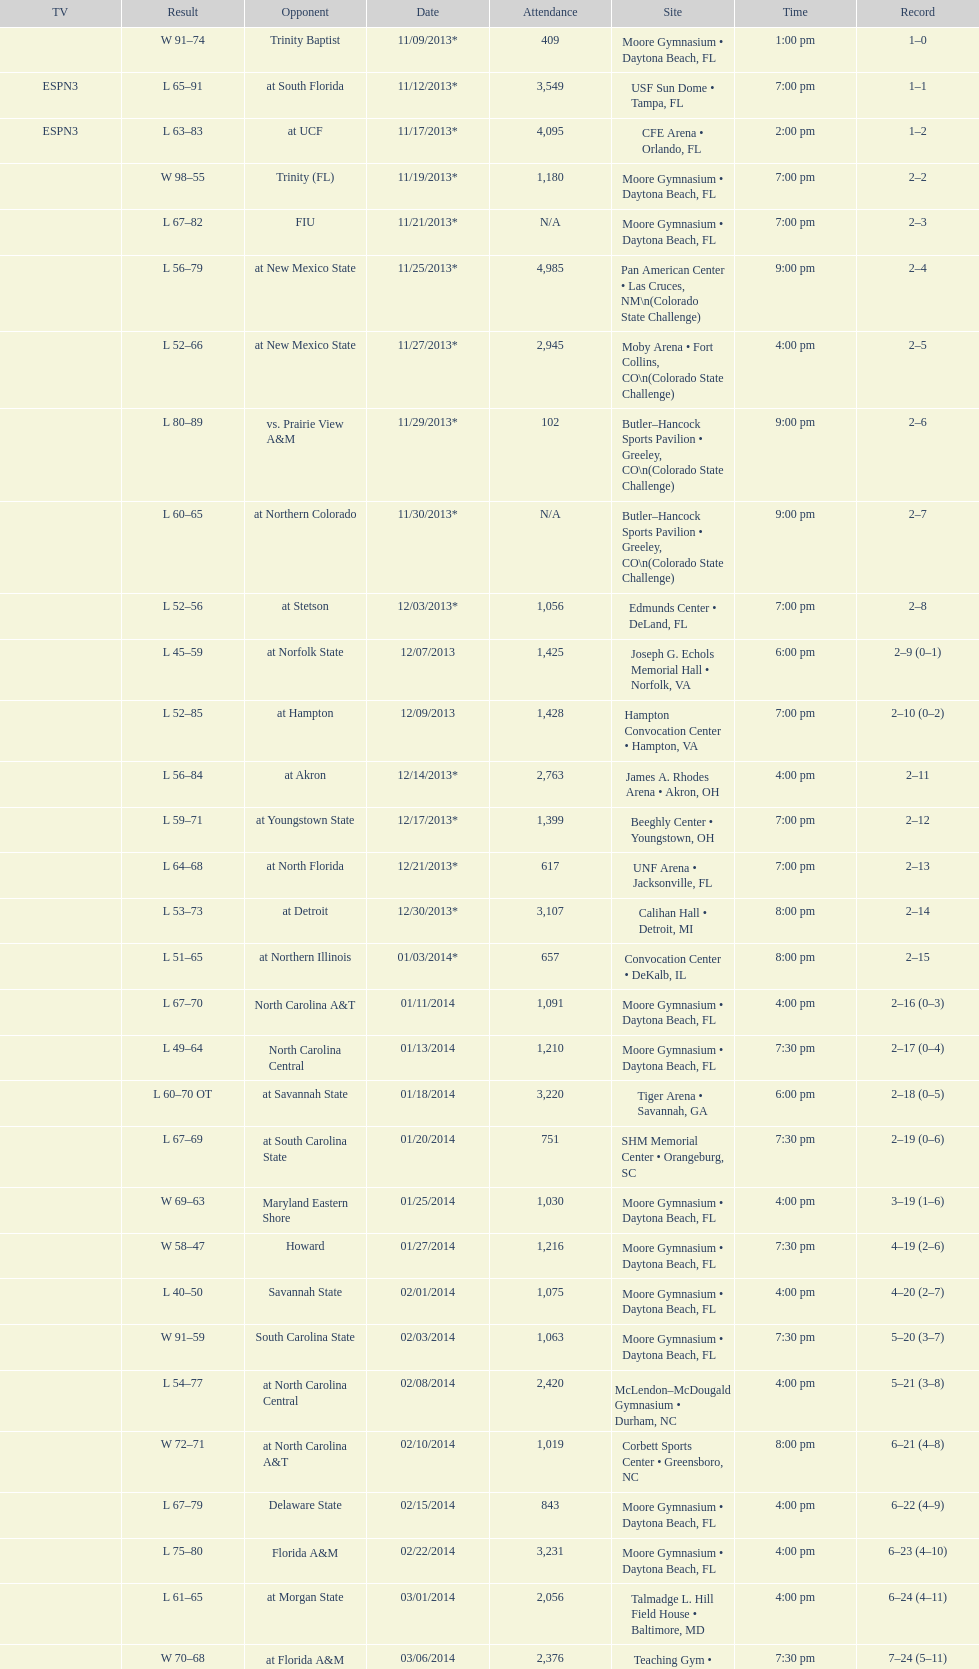What was the overall number of attendees on november 9, 2013? 409. 